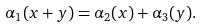<formula> <loc_0><loc_0><loc_500><loc_500>\alpha _ { 1 } ( x + y ) = \alpha _ { 2 } ( x ) + \alpha _ { 3 } ( y ) .</formula> 